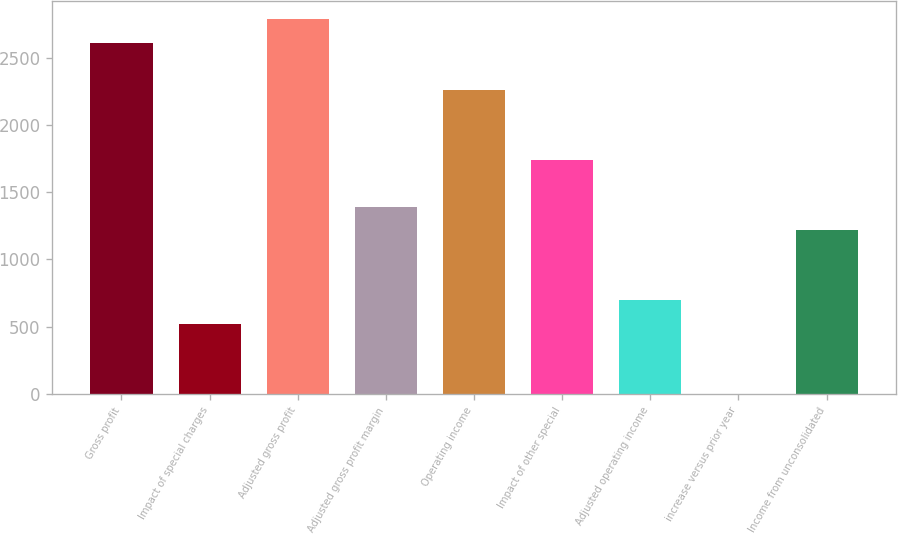<chart> <loc_0><loc_0><loc_500><loc_500><bar_chart><fcel>Gross profit<fcel>Impact of special charges<fcel>Adjusted gross profit<fcel>Adjusted gross profit margin<fcel>Operating income<fcel>Impact of other special<fcel>Adjusted operating income<fcel>increase versus prior year<fcel>Income from unconsolidated<nl><fcel>2611.5<fcel>523.02<fcel>2785.54<fcel>1393.22<fcel>2263.42<fcel>1741.3<fcel>697.06<fcel>0.9<fcel>1219.18<nl></chart> 